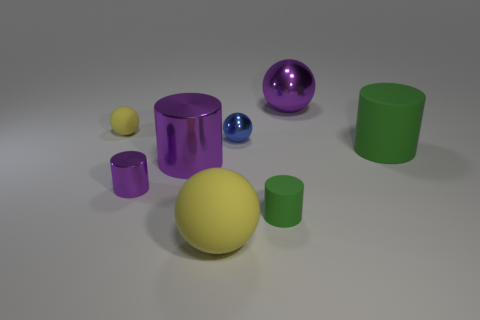Subtract all small purple cylinders. How many cylinders are left? 3 Add 2 tiny yellow balls. How many objects exist? 10 Subtract all blue spheres. How many spheres are left? 3 Subtract 1 spheres. How many spheres are left? 3 Subtract all gray cylinders. Subtract all red spheres. How many cylinders are left? 4 Subtract all green cubes. How many yellow balls are left? 2 Subtract all big green cylinders. Subtract all small balls. How many objects are left? 5 Add 3 big rubber objects. How many big rubber objects are left? 5 Add 4 large blue rubber spheres. How many large blue rubber spheres exist? 4 Subtract 2 purple cylinders. How many objects are left? 6 